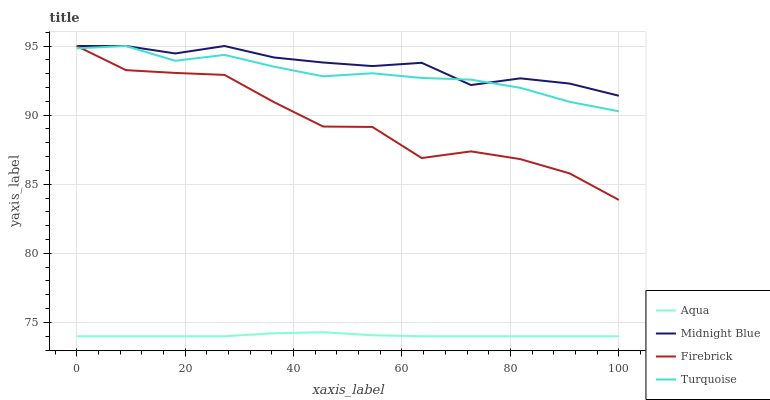Does Turquoise have the minimum area under the curve?
Answer yes or no. No. Does Turquoise have the maximum area under the curve?
Answer yes or no. No. Is Turquoise the smoothest?
Answer yes or no. No. Is Turquoise the roughest?
Answer yes or no. No. Does Turquoise have the lowest value?
Answer yes or no. No. Does Aqua have the highest value?
Answer yes or no. No. Is Aqua less than Firebrick?
Answer yes or no. Yes. Is Firebrick greater than Aqua?
Answer yes or no. Yes. Does Aqua intersect Firebrick?
Answer yes or no. No. 